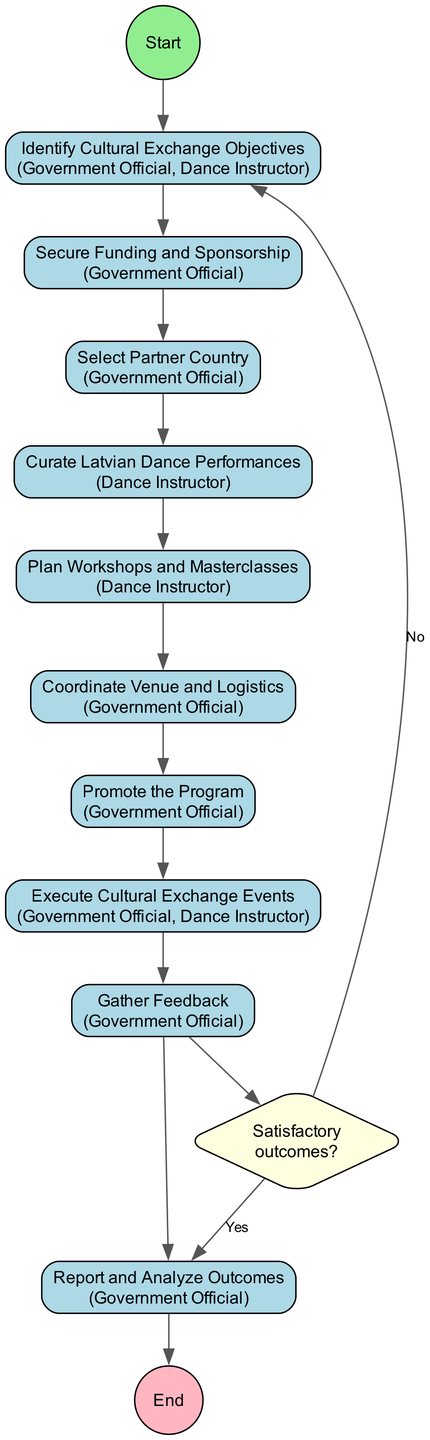What is the starting activity in the diagram? The starting activity is represented by the first node connected from the 'Start' node. According to the diagram, this activity is "Identify Cultural Exchange Objectives."
Answer: Identify Cultural Exchange Objectives How many activities are there in total? The diagram lists a sequence of activities from the start to the end. Counting all the activities provided, there are ten activities in total.
Answer: 10 Which activity directly follows "Select Partner Country"? The activity that follows "Select Partner Country" can be determined by following the edges from that node. The next connected activity is "Curate Latvian Dance Performances."
Answer: Curate Latvian Dance Performances Who are the actors involved in the "Execute Cultural Exchange Events" activity? Each activity node contains information about the associated actors. For "Execute Cultural Exchange Events," the actors listed are the “Government Official” and “Dance Instructor.”
Answer: Government Official, Dance Instructor What happens if the outcomes are not satisfactory after gathering feedback? The diagram indicates a decision point after the "Gather Feedback" activity, where if the outcomes are not satisfactory, the flow returns back to "Identify Cultural Exchange Objectives." Thus, the process would restart.
Answer: Return to Identify Cultural Exchange Objectives How many actors are involved in the curation of Latvian dance performances? Referring to the "Curate Latvian Dance Performances" activity, it specifies only one actor: the "Dance Instructor."
Answer: 1 Which activity is the last one before reporting and analyzing outcomes? To find the last activity before "Report and Analyze Outcomes," we look at the connections leading into it. The last preceding activity is "Gather Feedback."
Answer: Gather Feedback Which activity has only one actor associated with it? By reviewing the activity nodes and their listed actors, the activity "Curate Latvian Dance Performances" is unique as it has only the "Dance Instructor" listed as its actor.
Answer: Curate Latvian Dance Performances What is the decision question asked in the diagram? The decision point follows the "Gather Feedback" activity and poses the question "Satisfactory outcomes?" This is where the flow diverges based on the feedback received.
Answer: Satisfactory outcomes? 